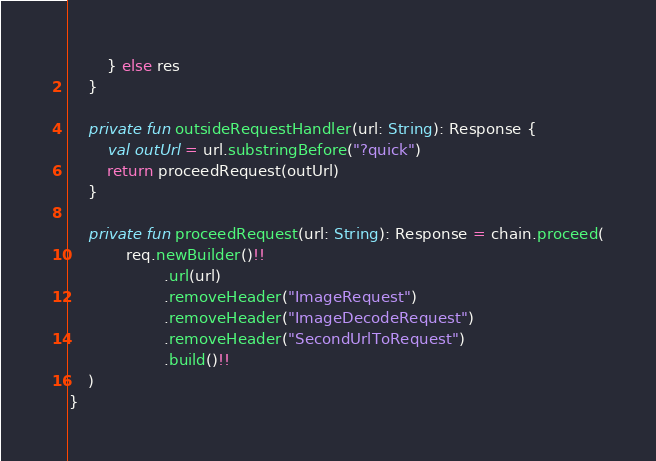Convert code to text. <code><loc_0><loc_0><loc_500><loc_500><_Kotlin_>        } else res
    }

    private fun outsideRequestHandler(url: String): Response {
        val outUrl = url.substringBefore("?quick")
        return proceedRequest(outUrl)
    }

    private fun proceedRequest(url: String): Response = chain.proceed(
            req.newBuilder()!!
                    .url(url)
                    .removeHeader("ImageRequest")
                    .removeHeader("ImageDecodeRequest")
                    .removeHeader("SecondUrlToRequest")
                    .build()!!
    )
}</code> 